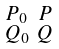Convert formula to latex. <formula><loc_0><loc_0><loc_500><loc_500>\begin{smallmatrix} P _ { 0 } & P \\ Q _ { 0 } & Q \end{smallmatrix}</formula> 